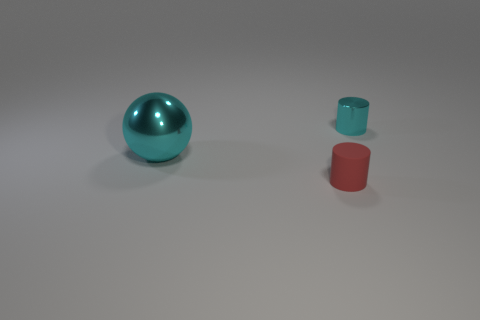Add 3 big cyan cylinders. How many objects exist? 6 Subtract 1 cylinders. How many cylinders are left? 1 Subtract all cylinders. How many objects are left? 1 Add 3 large cylinders. How many large cylinders exist? 3 Subtract 0 gray blocks. How many objects are left? 3 Subtract all cyan cylinders. Subtract all blue balls. How many cylinders are left? 1 Subtract all tiny red matte things. Subtract all large balls. How many objects are left? 1 Add 2 cyan shiny balls. How many cyan shiny balls are left? 3 